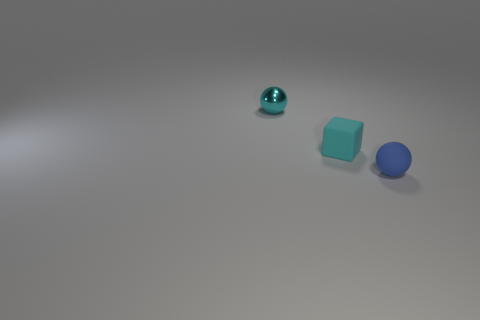Are there any other things that are made of the same material as the tiny cyan ball?
Provide a short and direct response. No. What number of other objects are the same shape as the tiny cyan matte object?
Give a very brief answer. 0. There is a small sphere that is left of the tiny blue matte object; is it the same color as the matte object that is on the left side of the blue rubber sphere?
Make the answer very short. Yes. How many tiny objects are either cyan rubber cubes or red cubes?
Your response must be concise. 1. The small ball on the left side of the tiny sphere that is on the right side of the small cyan metallic ball is made of what material?
Provide a succinct answer. Metal. What number of metallic things are small cyan cubes or tiny brown blocks?
Your answer should be very brief. 0. There is another thing that is the same shape as the tiny blue thing; what color is it?
Ensure brevity in your answer.  Cyan. How many tiny objects are the same color as the small rubber sphere?
Your answer should be very brief. 0. Are there any small cubes that are to the right of the tiny ball that is behind the blue ball?
Make the answer very short. Yes. How many small spheres are on the left side of the blue thing and in front of the tiny cyan metallic object?
Provide a succinct answer. 0. 